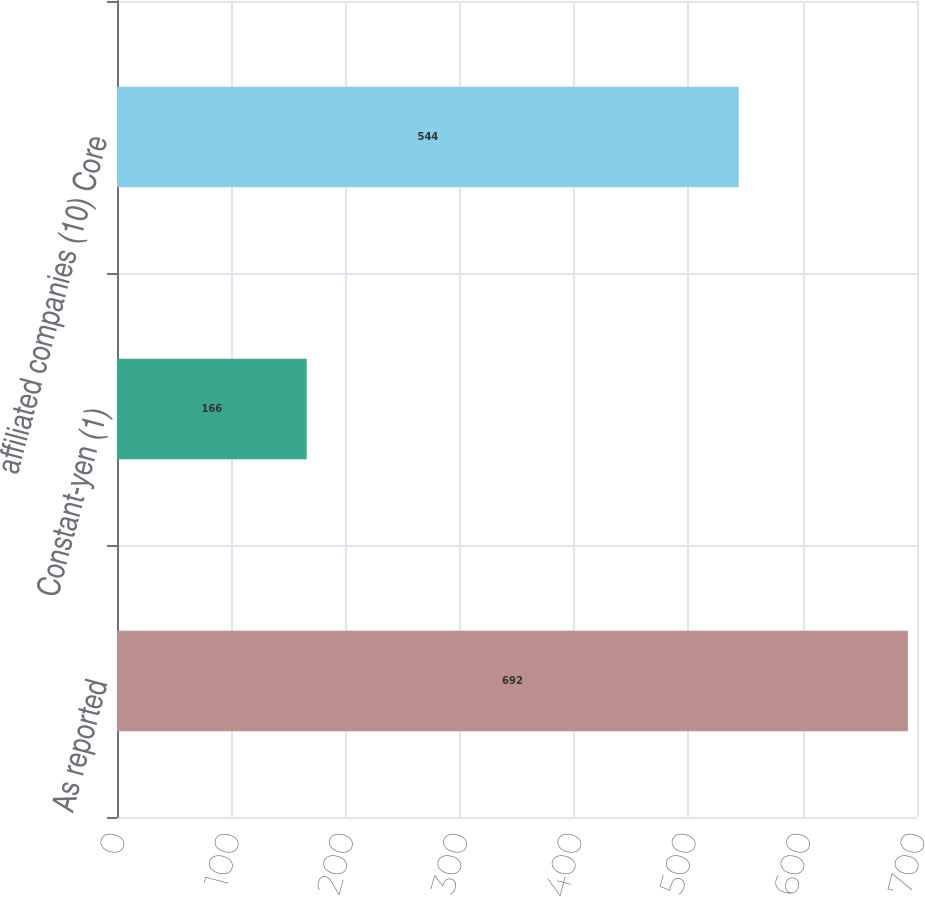Convert chart. <chart><loc_0><loc_0><loc_500><loc_500><bar_chart><fcel>As reported<fcel>Constant-yen (1)<fcel>affiliated companies (10) Core<nl><fcel>692<fcel>166<fcel>544<nl></chart> 